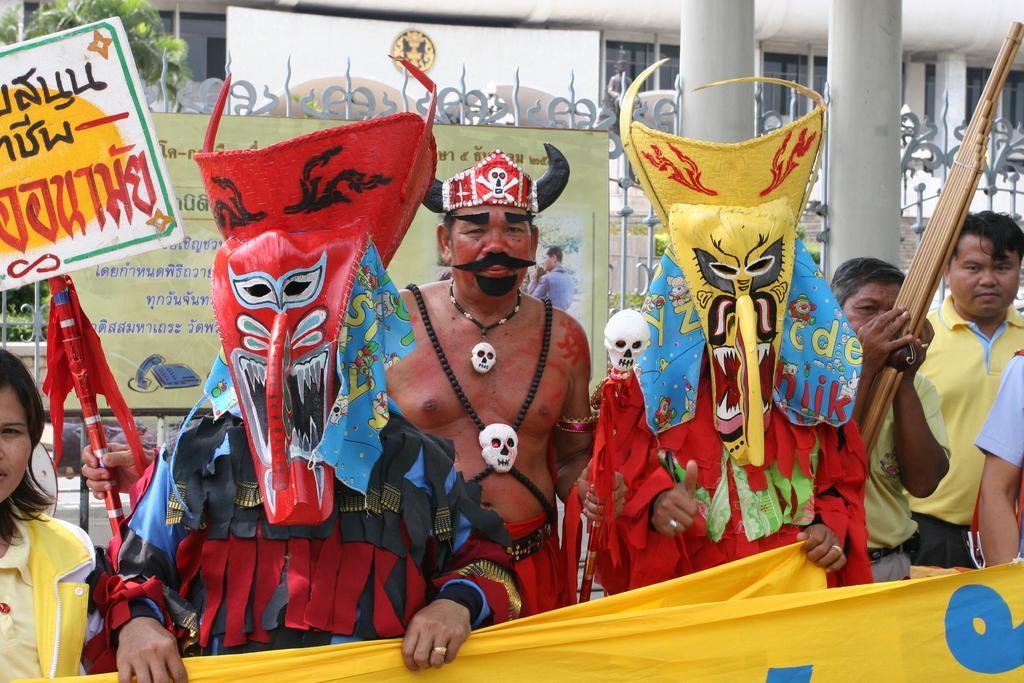How would you summarize this image in a sentence or two? In this image I can see people among them and some are wearing costumes. I can also see these two people are holding banners in hands. In the background I can see a board which has something written on it. Some of them are holding some objects in hands. 